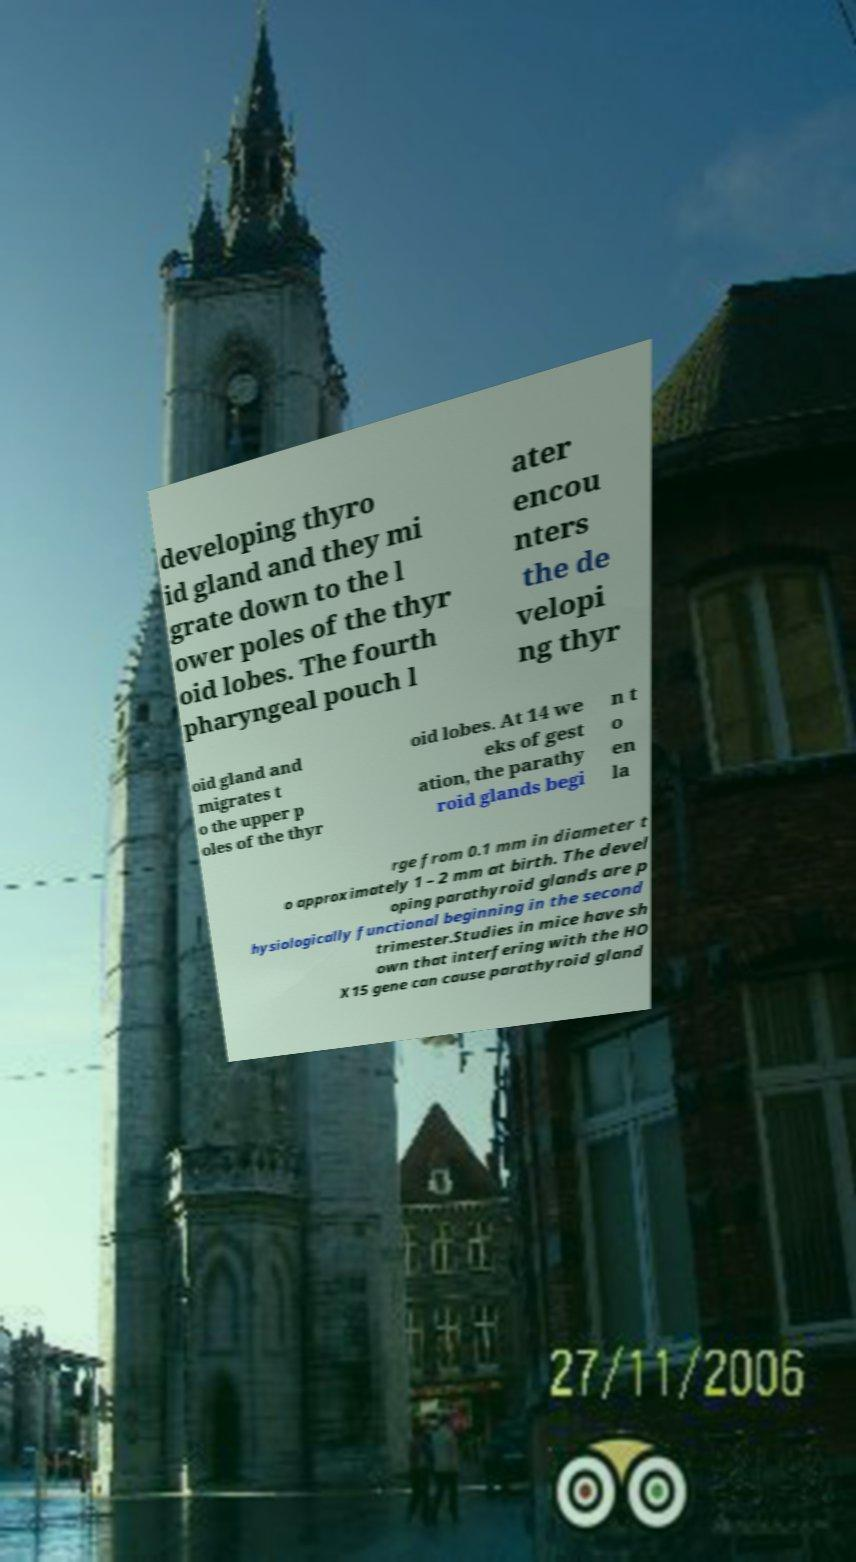Can you accurately transcribe the text from the provided image for me? developing thyro id gland and they mi grate down to the l ower poles of the thyr oid lobes. The fourth pharyngeal pouch l ater encou nters the de velopi ng thyr oid gland and migrates t o the upper p oles of the thyr oid lobes. At 14 we eks of gest ation, the parathy roid glands begi n t o en la rge from 0.1 mm in diameter t o approximately 1 – 2 mm at birth. The devel oping parathyroid glands are p hysiologically functional beginning in the second trimester.Studies in mice have sh own that interfering with the HO X15 gene can cause parathyroid gland 